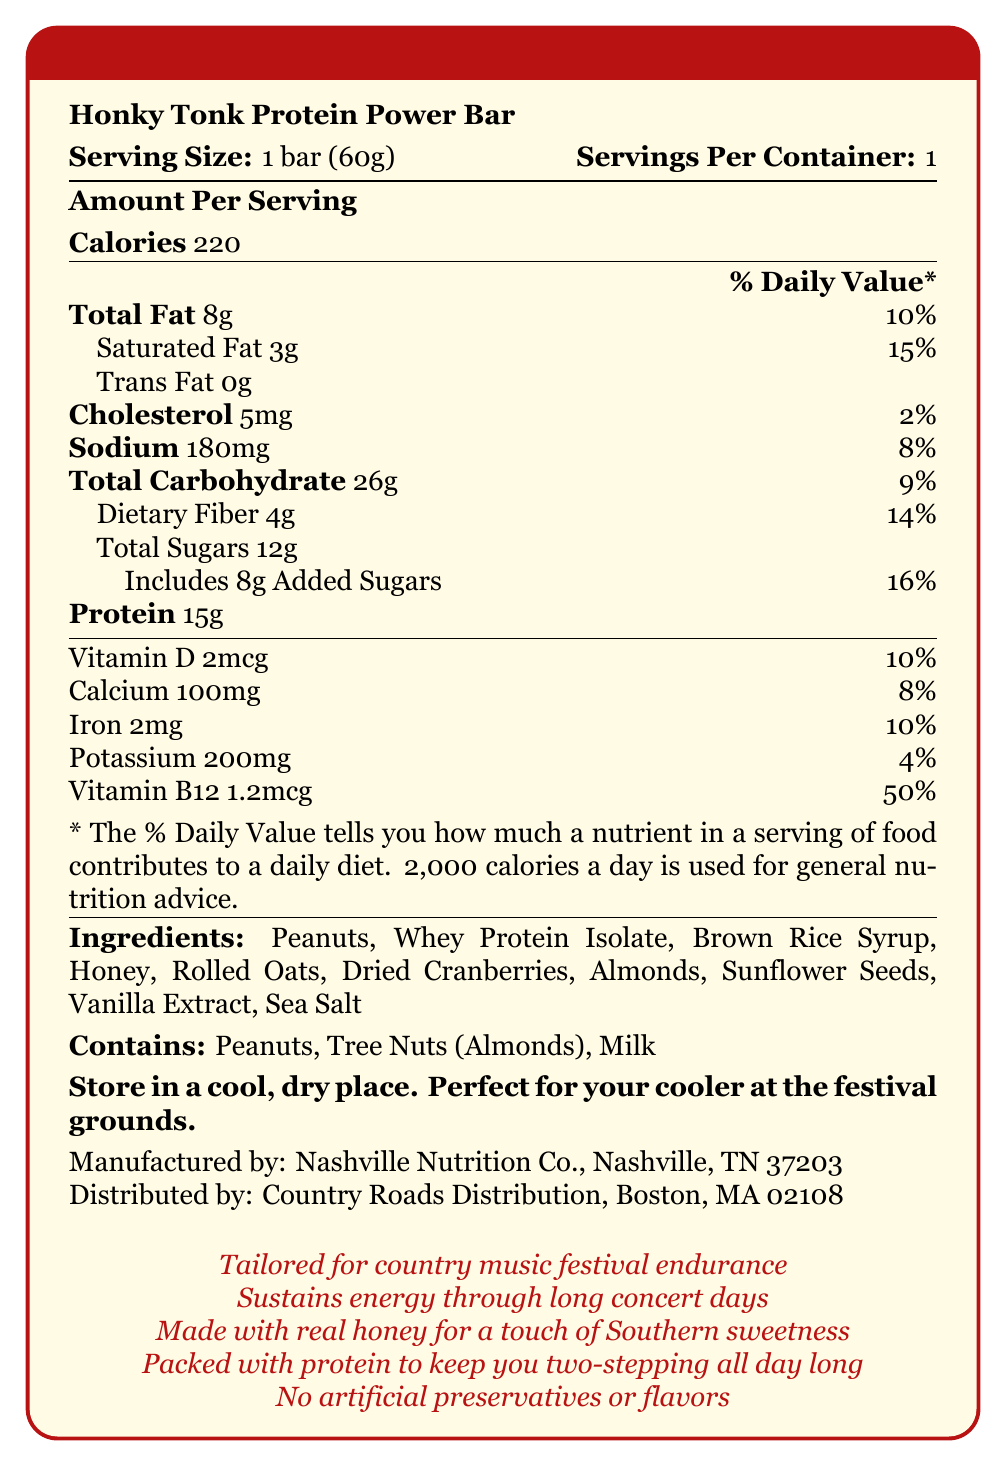what is the serving size of the Honky Tonk Protein Power Bar? The serving size is stated clearly under "Serving Size" which is 1 bar (60g).
Answer: 1 bar (60g) how many total calories are in one serving of the protein bar? The total calories per serving are listed as 220 under "Calories".
Answer: 220 what are the main ingredients of the protein bar? The main ingredients are listed under "Ingredients".
Answer: Peanuts, Whey Protein Isolate, Brown Rice Syrup, Honey, Rolled Oats, Dried Cranberries, Almonds, Sunflower Seeds, Vanilla Extract, Sea Salt how much protein does the Honky Tonk Protein Power Bar contain? The amount of protein is found under "Protein" which states 15g.
Answer: 15g what is the percentage of the daily value of vitamin B12 provided by this protein bar? The daily value percentage for vitamin B12 is 50%, as indicated in the section listing Vitamin B12.
Answer: 50% which claim is made about the protein bar? (Choose one) A. Contains artificial preservatives B. Vegan friendly C. Packed with protein to keep you two-stepping all day long D. Gluten-free Option C is correct. The claim is "Packed with protein to keep you two-stepping all day long" as listed in the marketing claims.
Answer: C how many grams of added sugars are there in the protein bar? A. 12g B. 10g C. 8g D. 5g The correct answer is 8g. The document states "Includes 8g Added Sugars".
Answer: C is the protein bar suitable for someone with a peanut allergy? The bar contains peanuts. This information is explicitly stated under "Contains: Peanuts".
Answer: No does the protein bar contain any artificial preservatives or flavors? The document specifically states "No artificial preservatives or flavors" under the marketing claims.
Answer: No provide a summary of the nutrition label for the Honky Tonk Protein Power Bar The summary encapsulates all the nutritional information, key ingredients, allergen information, marketing claims, and storage instructions as described in the document.
Answer: The Honky Tonk Protein Power Bar contains 220 calories per serving (one bar). It has 15g of protein, 8g of total fat (including 3g of saturated fat), and 12g of sugars (including 8g of added sugars). It also provides various vitamins and minerals, including 50% of the daily value of Vitamin B12. The bar is made of ingredients such as peanuts, whey protein isolate, and honey, and does not contain any artificial preservatives or flavors. It is marketed for sustaining energy during long country music festivals. The bar should be stored in a cool, dry place. how long is the product’s shelf life? The document does not provide any information about the product's shelf life.
Answer: I don't know 